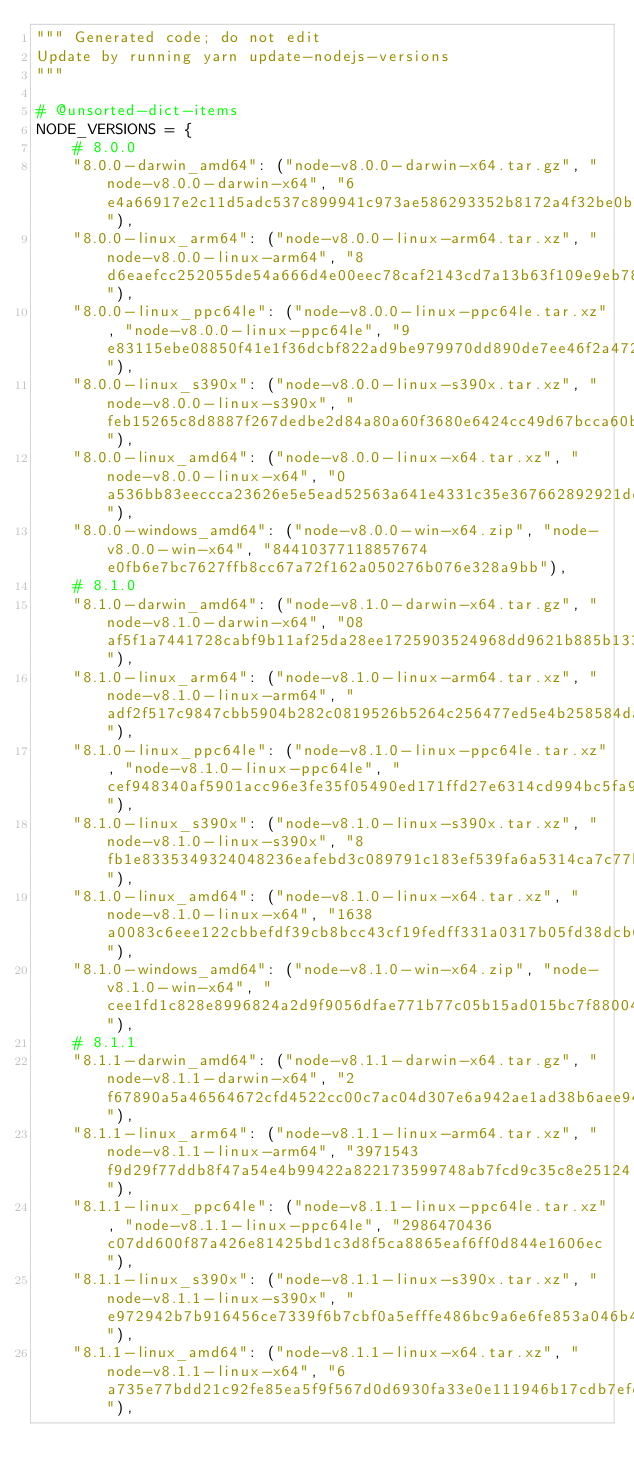Convert code to text. <code><loc_0><loc_0><loc_500><loc_500><_Python_>""" Generated code; do not edit
Update by running yarn update-nodejs-versions
"""

# @unsorted-dict-items
NODE_VERSIONS = {
    # 8.0.0
    "8.0.0-darwin_amd64": ("node-v8.0.0-darwin-x64.tar.gz", "node-v8.0.0-darwin-x64", "6e4a66917e2c11d5adc537c899941c973ae586293352b8172a4f32be0b7f0300"),
    "8.0.0-linux_arm64": ("node-v8.0.0-linux-arm64.tar.xz", "node-v8.0.0-linux-arm64", "8d6eaefcc252055de54a666d4e00eec78caf2143cd7a13b63f109e9eb78a795e"),
    "8.0.0-linux_ppc64le": ("node-v8.0.0-linux-ppc64le.tar.xz", "node-v8.0.0-linux-ppc64le", "9e83115ebe08850f41e1f36dcbf822ad9be979970dd890de7ee46f2a472de29d"),
    "8.0.0-linux_s390x": ("node-v8.0.0-linux-s390x.tar.xz", "node-v8.0.0-linux-s390x", "feb15265c8d8887f267dedbe2d84a80a60f3680e6424cc49d67bcca60bb66794"),
    "8.0.0-linux_amd64": ("node-v8.0.0-linux-x64.tar.xz", "node-v8.0.0-linux-x64", "0a536bb83eeccca23626e5e5ead52563a641e4331c35e367662892921dc7e8a4"),
    "8.0.0-windows_amd64": ("node-v8.0.0-win-x64.zip", "node-v8.0.0-win-x64", "84410377118857674e0fb6e7bc7627ffb8cc67a72f162a050276b076e328a9bb"),
    # 8.1.0
    "8.1.0-darwin_amd64": ("node-v8.1.0-darwin-x64.tar.gz", "node-v8.1.0-darwin-x64", "08af5f1a7441728cabf9b11af25da28ee1725903524968dd9621b885b13303c7"),
    "8.1.0-linux_arm64": ("node-v8.1.0-linux-arm64.tar.xz", "node-v8.1.0-linux-arm64", "adf2f517c9847cbb5904b282c0819526b5264c256477ed5e4b258584daa1a2ea"),
    "8.1.0-linux_ppc64le": ("node-v8.1.0-linux-ppc64le.tar.xz", "node-v8.1.0-linux-ppc64le", "cef948340af5901acc96e3fe35f05490ed171ffd27e6314cd994bc5fa94488b7"),
    "8.1.0-linux_s390x": ("node-v8.1.0-linux-s390x.tar.xz", "node-v8.1.0-linux-s390x", "8fb1e8335349324048236eafebd3c089791c183ef539fa6a5314ca7c77b5f056"),
    "8.1.0-linux_amd64": ("node-v8.1.0-linux-x64.tar.xz", "node-v8.1.0-linux-x64", "1638a0083c6eee122cbbefdf39cb8bcc43cf19fedff331a0317b05fd38dcb6df"),
    "8.1.0-windows_amd64": ("node-v8.1.0-win-x64.zip", "node-v8.1.0-win-x64", "cee1fd1c828e8996824a2d9f9056dfae771b77c05b15ad015bc7f8800409215c"),
    # 8.1.1
    "8.1.1-darwin_amd64": ("node-v8.1.1-darwin-x64.tar.gz", "node-v8.1.1-darwin-x64", "2f67890a5a46564672cfd4522cc00c7ac04d307e6a942ae1ad38b6aee94c29e2"),
    "8.1.1-linux_arm64": ("node-v8.1.1-linux-arm64.tar.xz", "node-v8.1.1-linux-arm64", "3971543f9d29f77ddb8f47a54e4b99422a822173599748ab7fcd9c35c8e25124"),
    "8.1.1-linux_ppc64le": ("node-v8.1.1-linux-ppc64le.tar.xz", "node-v8.1.1-linux-ppc64le", "2986470436c07dd600f87a426e81425bd1c3d8f5ca8865eaf6ff0d844e1606ec"),
    "8.1.1-linux_s390x": ("node-v8.1.1-linux-s390x.tar.xz", "node-v8.1.1-linux-s390x", "e972942b7b916456ce7339f6b7cbf0a5efffe486bc9a6e6fe853a046b4a3beda"),
    "8.1.1-linux_amd64": ("node-v8.1.1-linux-x64.tar.xz", "node-v8.1.1-linux-x64", "6a735e77bdd21c92fe85ea5f9f567d0d6930fa33e0e111946b17cdb7efefb8d5"),</code> 